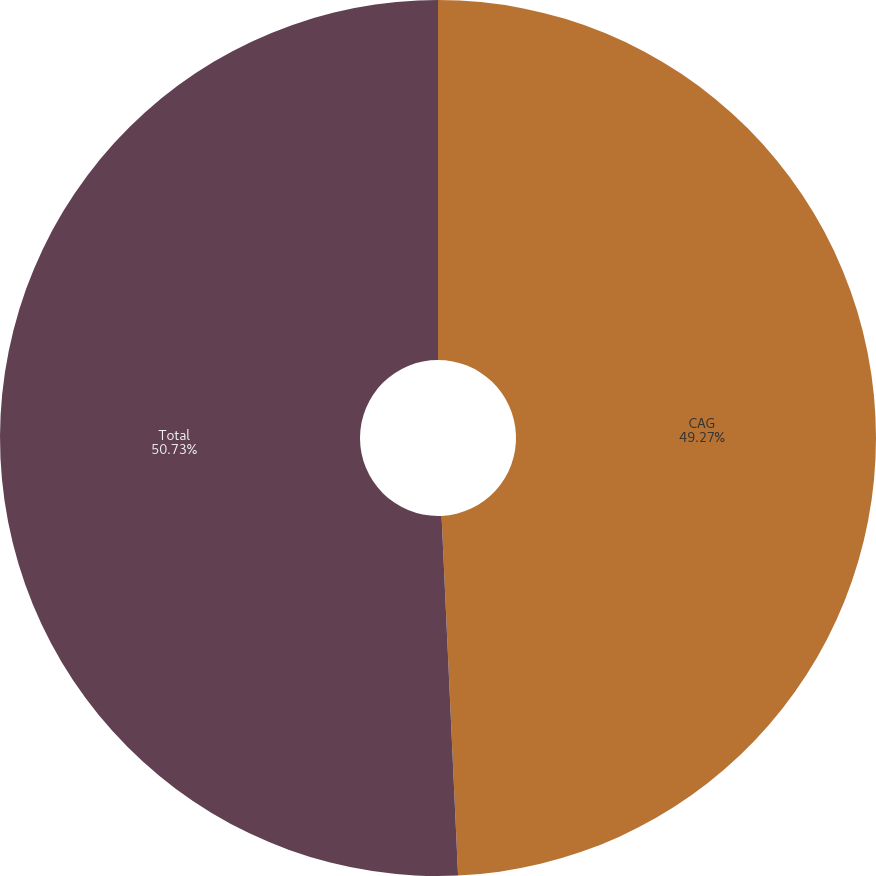Convert chart to OTSL. <chart><loc_0><loc_0><loc_500><loc_500><pie_chart><fcel>CAG<fcel>Total<nl><fcel>49.27%<fcel>50.73%<nl></chart> 